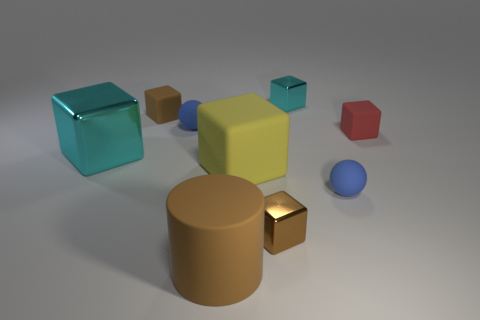There is a small cyan thing that is the same shape as the large metal object; what is its material? The small cyan object appears to have a smooth surface and is reflective, similar to the large metal object, suggesting it is likely made of a metallic material as well. 